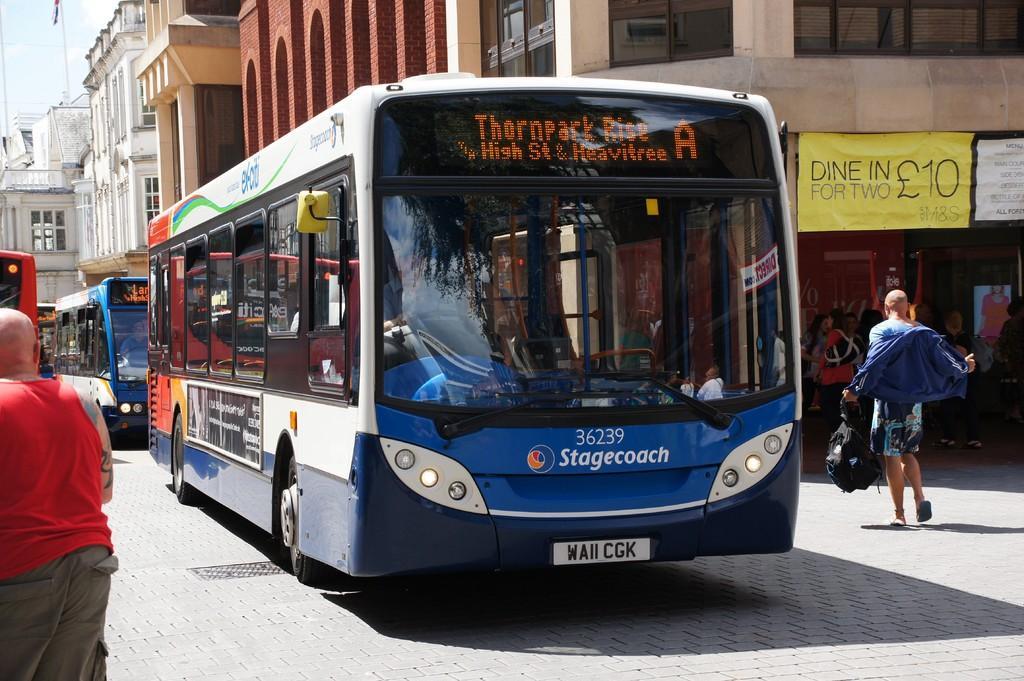Could you give a brief overview of what you see in this image? In this image we can see a group of vehicles and buildings. On both sides of the image we can see the persons. On the right side, we can see banners with text on the building. In the top left, we can see the sky and a pole with a flag. 